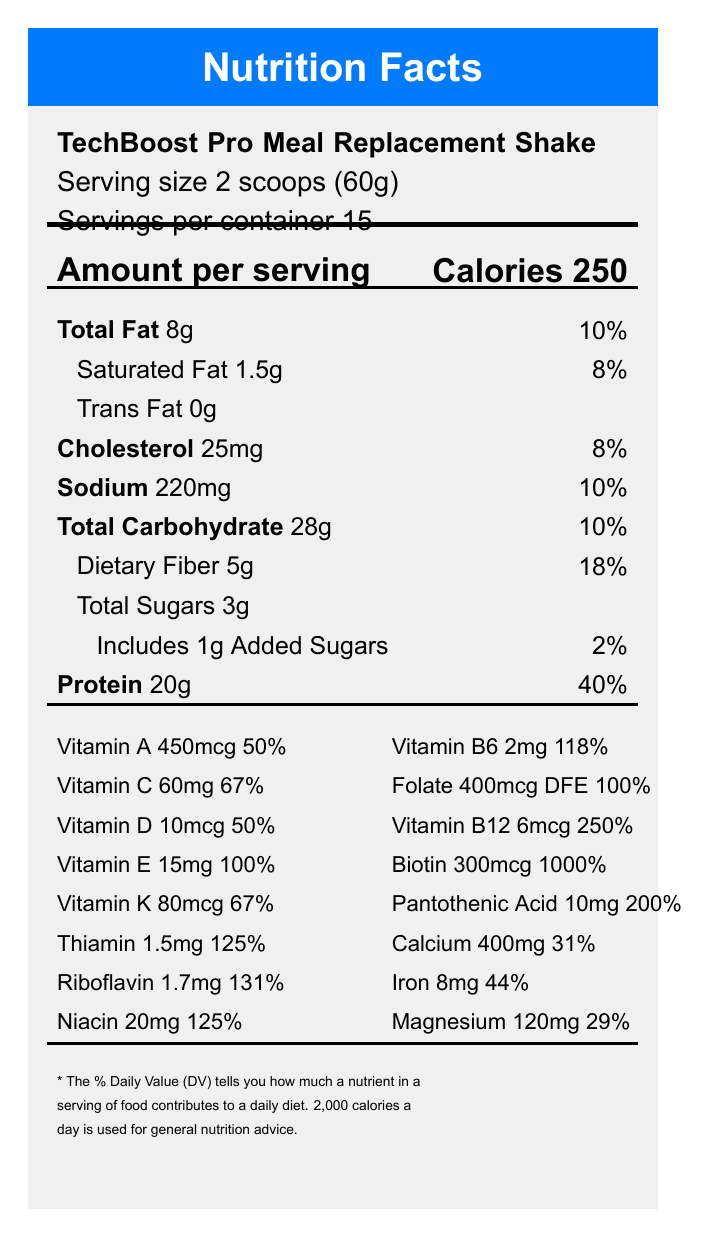what is the serving size? The serving size is stated at the beginning of the document as "Serving size 2 scoops (60g)".
Answer: 2 scoops (60g) how many calories are in a serving? The amount of calories per serving is listed under the "Amount per serving" section as "Calories 250".
Answer: 250 calories what is the daily value percentage of protein per serving? The daily value percentage of protein is mentioned under the "Protein" section as 40%.
Answer: 40% how many servings are in one container? The number of servings per container is mentioned at the beginning of the document as "Servings per container 15".
Answer: 15 servings per container what is the amount of saturated fat in each serving? The amount of saturated fat per serving is listed as "Saturated Fat 1.5g".
Answer: 1.5g what is the total amount of sugars per serving? A. 0g B. 1g C. 3g D. 5g The amount of total sugars per serving is listed as "Total Sugars 3g".
Answer: C. 3g which vitamin has the highest daily value percentage per serving? A. Vitamin A B. Vitamin B12 C. Vitamin E D. Vitamin C Vitamin E has the highest daily value percentage per serving at 1000%.
Answer: D. Vitamin E is the product's website using SSL encryption? The document states "This product's website uses 256-bit SSL encryption for secure online ordering."
Answer: Yes does this product contain any allergens? The document specifies that it "Contains milk. Produced in a facility that also processes soy, tree nuts, and eggs."
Answer: Yes summarize the main features of the TechBoost Pro Meal Replacement Shake. The document primarily discusses the nutritional content, special features, allergen information, preparation, and storage instructions of the TechBoost Pro Meal Replacement Shake.
Answer: The TechBoost Pro Meal Replacement Shake provides 250 calories per serving, with significant amounts of protein (20g per serving) and a range of vitamins and minerals. It also contains caffeine, L-theanine, omega-3 fatty acids, coenzyme Q10, and lutein. The product includes a QR code for detailed nutritional information, uses blockchain-verified ingredient sourcing, and offers AI-powered personalized nutrition recommendations. It is allergen-friendly but contains milk and is processed in a facility handling other allergens. The company ensures secure online ordering through 256-bit SSL encryption. what is the amount of Omega-3 fatty acids per serving? The document lists Omega-3 fatty acids as 1g per serving.
Answer: 1g how much Thiamin is there per serving? The amount of Thiamin per serving is mentioned as 1.5mg providing 125% of the daily value.
Answer: 1.5mg what are the storage instructions for this product? The storage instructions are clearly mentioned towards the end of the document.
Answer: Store in a cool, dry place. Refrigerate after opening and consume within 30 days. is there enough information to determine the flavor of the meal replacement shake? The document lists "Natural Flavors" among the ingredients but does not specify the exact flavor of the shake. Therefore, the exact flavor cannot be determined based on the provided visual information.
Answer: No what additional tech features are included with this product? The document lists multiple tech features such as a QR code for detailed nutritional information, blockchain-verified ingredient sourcing, and AI-powered personalized nutrition recommendations.
Answer: QR code on package links to detailed nutritional information, blockchain-verified ingredient sourcing, AI-powered personalized nutrition recommendations available through a companion app what is the sodium content per serving in percentage of daily value? A. 8% B. 10% C. 18% D. 20% The document indicates that the sodium content per serving is 220mg, which is 10% of the daily value.
Answer: B. 10% 